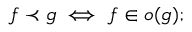<formula> <loc_0><loc_0><loc_500><loc_500>f \prec g \iff f \in o ( g ) ;</formula> 